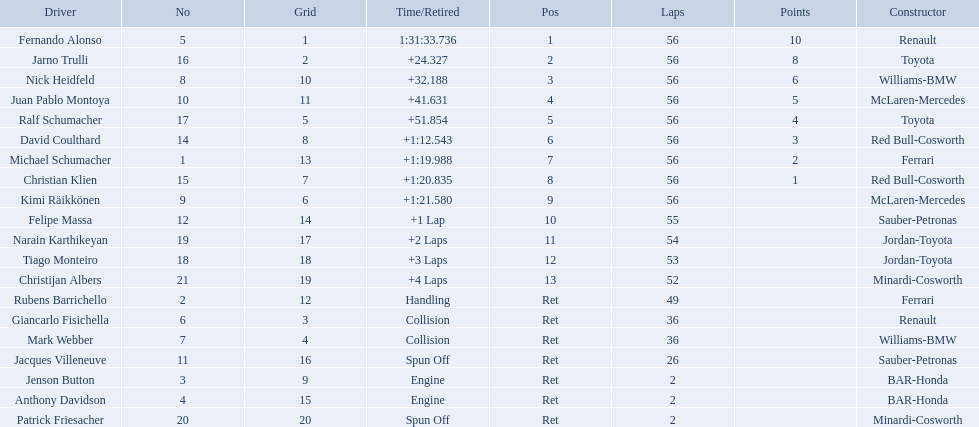Who raced during the 2005 malaysian grand prix? Fernando Alonso, Jarno Trulli, Nick Heidfeld, Juan Pablo Montoya, Ralf Schumacher, David Coulthard, Michael Schumacher, Christian Klien, Kimi Räikkönen, Felipe Massa, Narain Karthikeyan, Tiago Monteiro, Christijan Albers, Rubens Barrichello, Giancarlo Fisichella, Mark Webber, Jacques Villeneuve, Jenson Button, Anthony Davidson, Patrick Friesacher. What were their finishing times? 1:31:33.736, +24.327, +32.188, +41.631, +51.854, +1:12.543, +1:19.988, +1:20.835, +1:21.580, +1 Lap, +2 Laps, +3 Laps, +4 Laps, Handling, Collision, Collision, Spun Off, Engine, Engine, Spun Off. What was fernando alonso's finishing time? 1:31:33.736. 